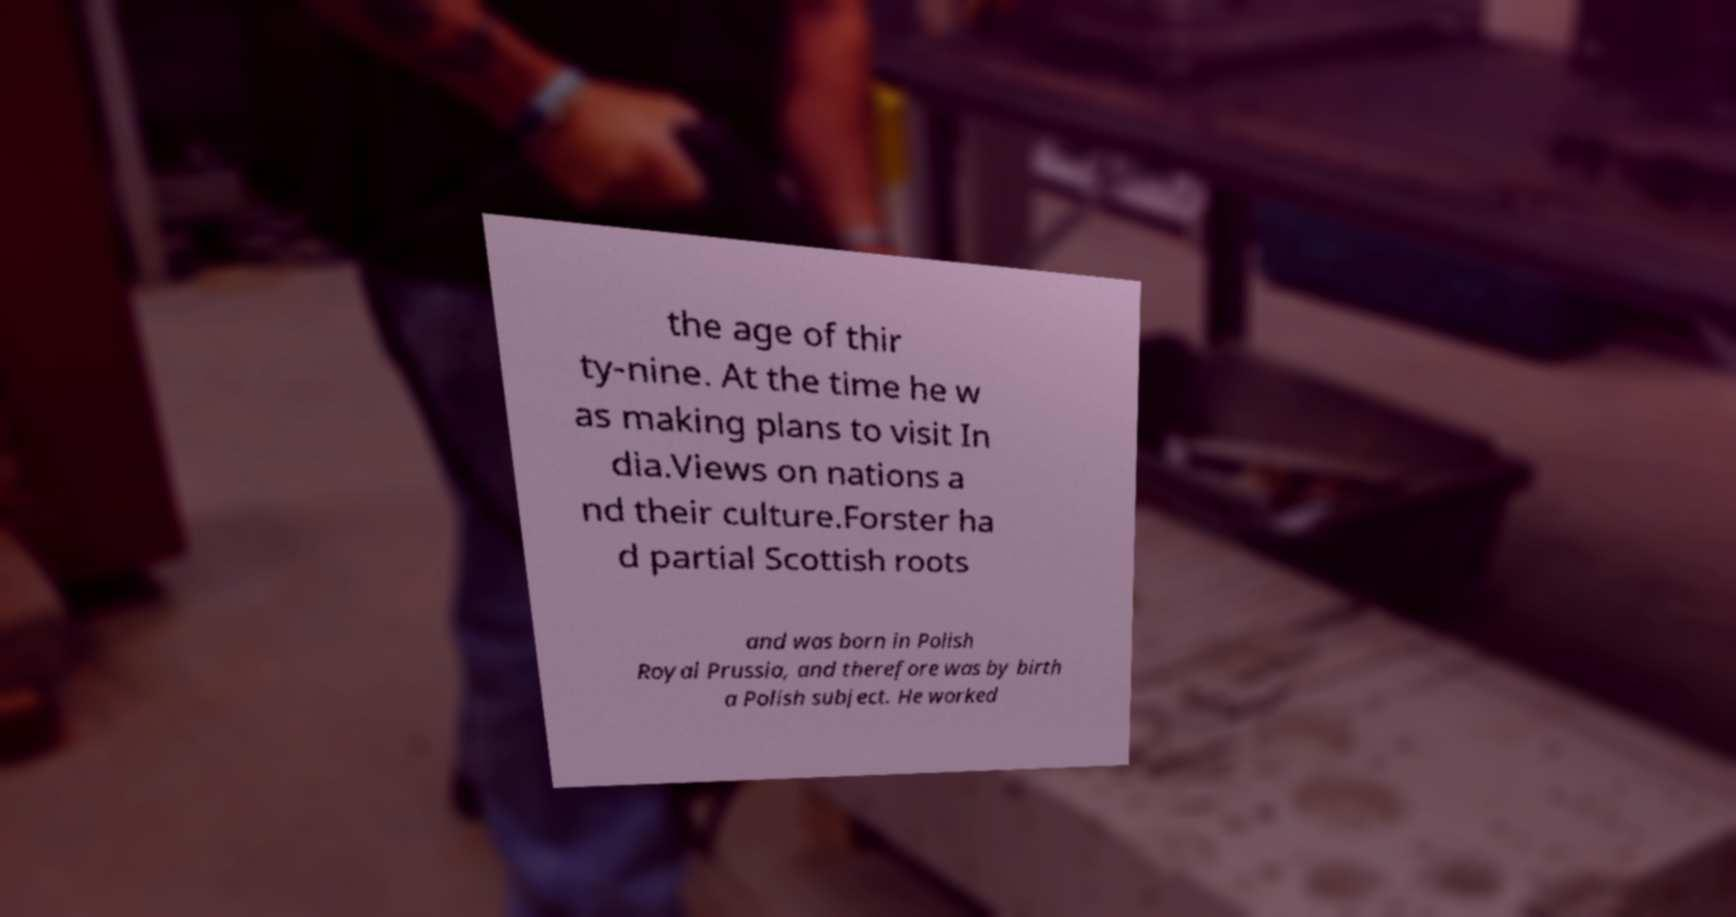For documentation purposes, I need the text within this image transcribed. Could you provide that? the age of thir ty-nine. At the time he w as making plans to visit In dia.Views on nations a nd their culture.Forster ha d partial Scottish roots and was born in Polish Royal Prussia, and therefore was by birth a Polish subject. He worked 